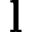<formula> <loc_0><loc_0><loc_500><loc_500>l</formula> 